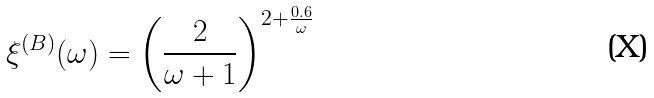Convert formula to latex. <formula><loc_0><loc_0><loc_500><loc_500>\xi ^ { ( B ) } ( \omega ) = \left ( \frac { 2 } { \omega + 1 } \right ) ^ { 2 + \frac { 0 . 6 } { \omega } }</formula> 